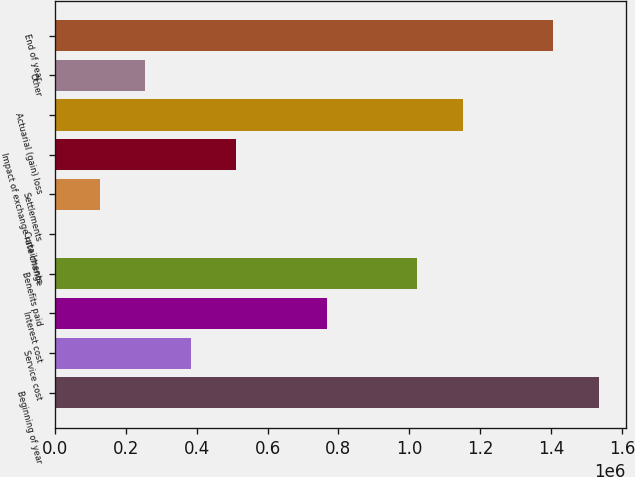<chart> <loc_0><loc_0><loc_500><loc_500><bar_chart><fcel>Beginning of year<fcel>Service cost<fcel>Interest cost<fcel>Benefits paid<fcel>Curtailments<fcel>Settlements<fcel>Impact of exchange rate change<fcel>Actuarial (gain) loss<fcel>Other<fcel>End of year<nl><fcel>1.53323e+06<fcel>383447<fcel>766708<fcel>1.02221e+06<fcel>186<fcel>127940<fcel>511200<fcel>1.14997e+06<fcel>255693<fcel>1.40548e+06<nl></chart> 